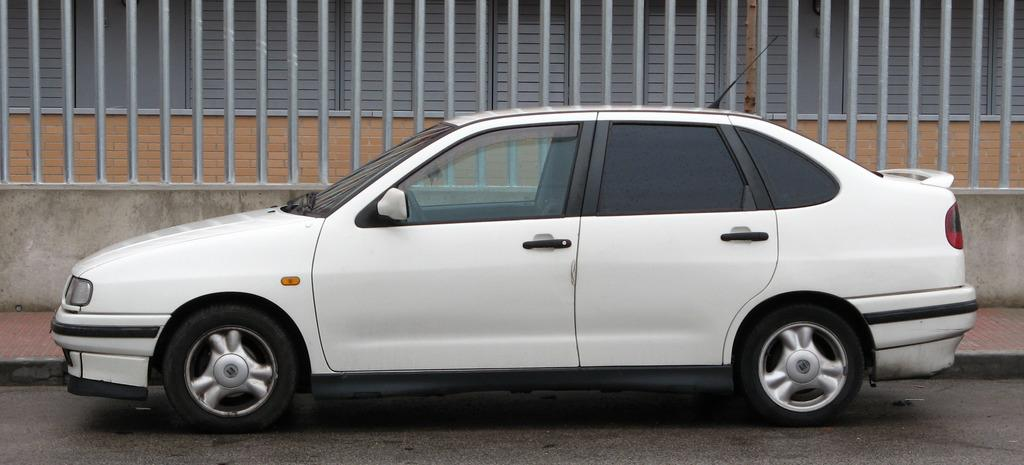What is the main subject in the center of the image? There is a car in the center of the image. What can be seen in the background of the image? There is a railing, a wall, and a building in the background of the image. What is at the bottom of the image? There is a road at the bottom of the image. How much milk does the goat produce in the image? There is no goat or milk present in the image. What tool is used to measure the distance between the car and the building in the image? The facts provided do not mention any measuring tool, and there is no need to measure the distance between the car and the building in the image. 